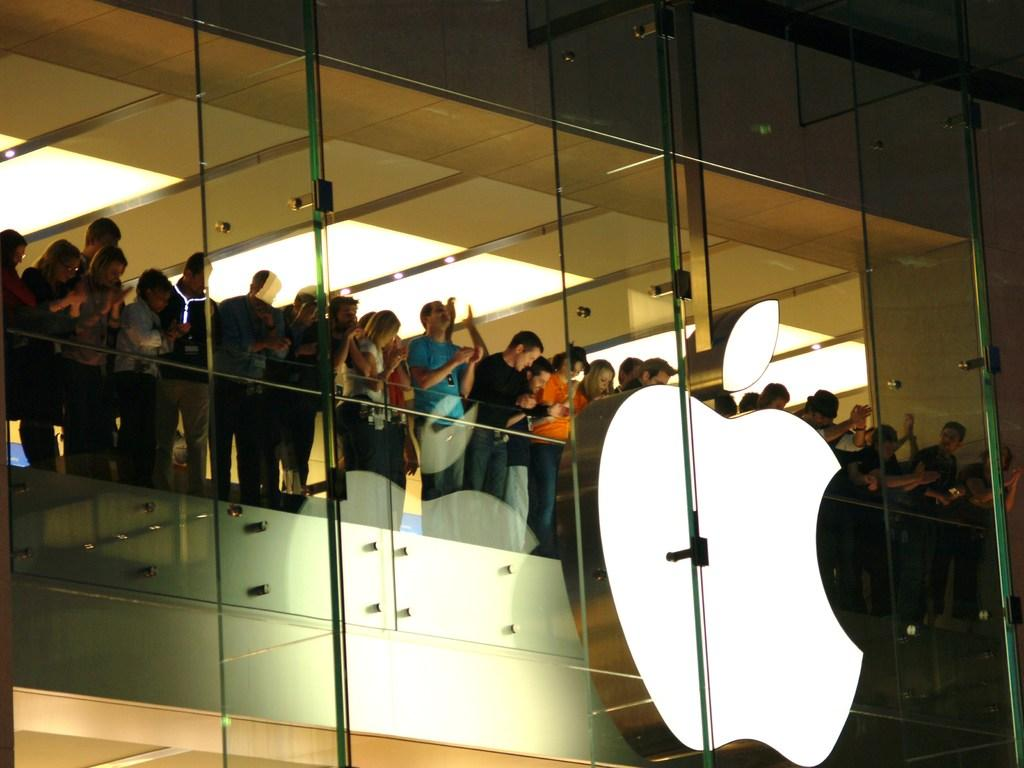What type of building is depicted in the image? There is a glass building in the image. What are the people near the glass railing doing? A group of people are standing near the glass railing in the building. What can be seen on the building or nearby? There is an icon visible in the image. What structural elements are present in the image? Bolts are present in the image. What can be seen above the people in the image? The ceiling with lights is visible in the image. What type of bean is being served in the image? There is no bean present in the image; it features a glass building with people near a glass railing. 